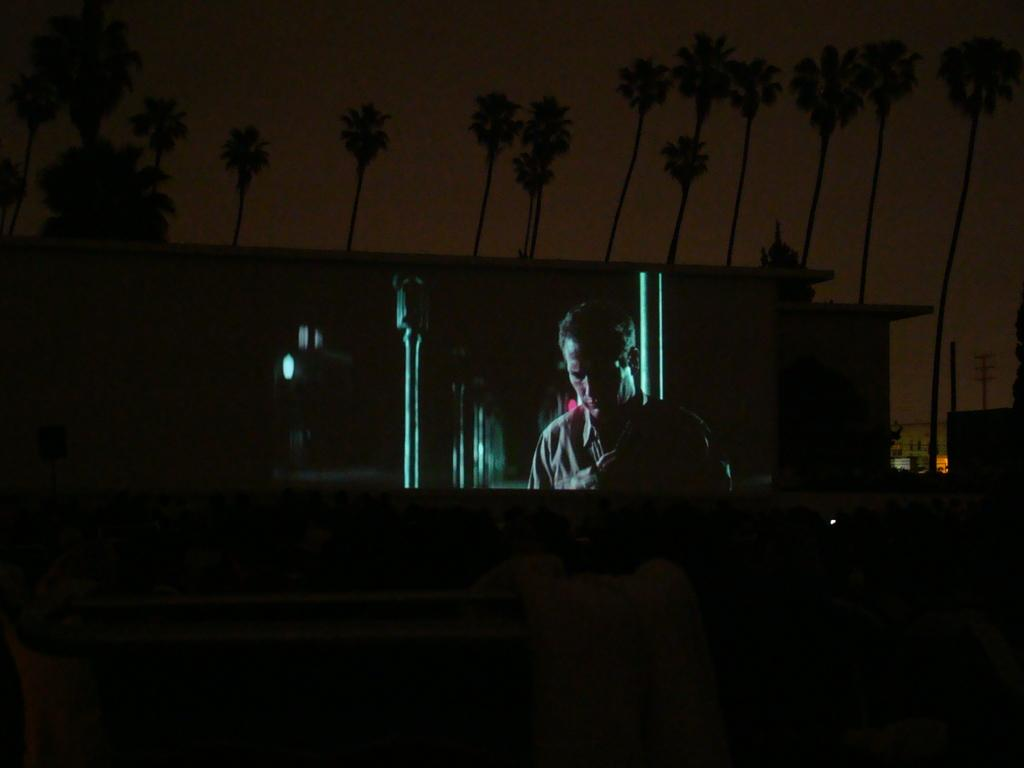What is present in the image? There is a person in the image. What is the white object at the bottom of the image? It is not specified what the white object is, but it is present at the bottom of the image. What can be seen in the background of the image? There are lights, buildings, and trees visible in the background of the image. What type of war is being depicted in the image? There is no depiction of war in the image; it features a person and a white object at the bottom, with lights, buildings, and trees in the background. 